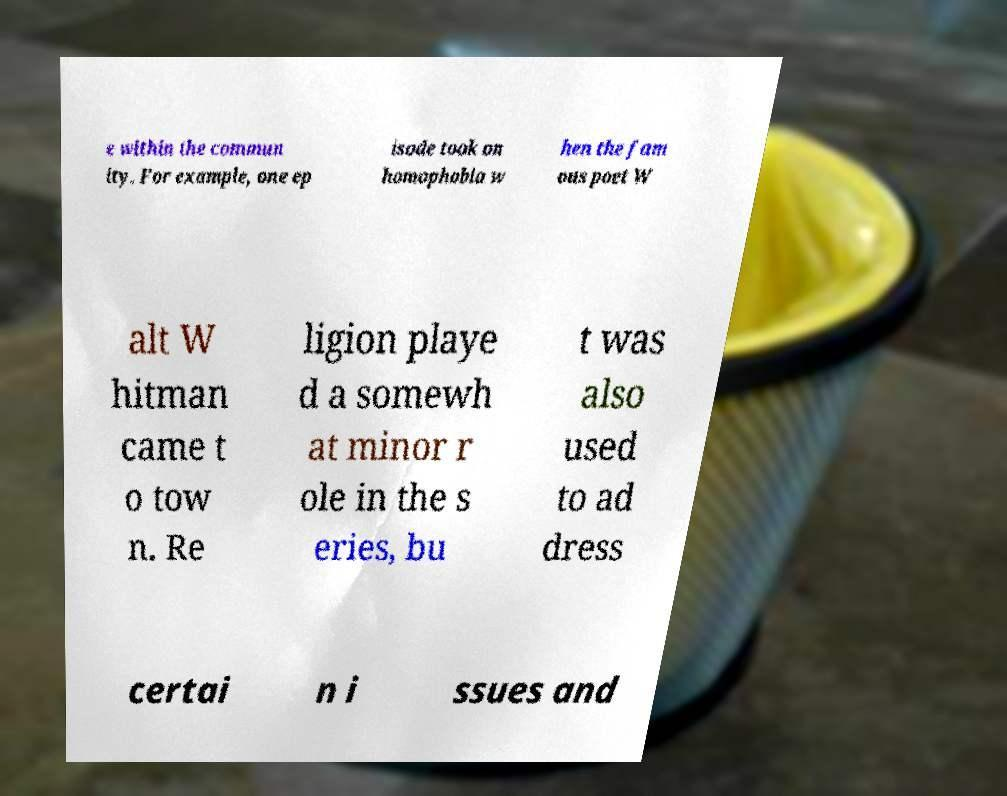Can you read and provide the text displayed in the image?This photo seems to have some interesting text. Can you extract and type it out for me? e within the commun ity. For example, one ep isode took on homophobia w hen the fam ous poet W alt W hitman came t o tow n. Re ligion playe d a somewh at minor r ole in the s eries, bu t was also used to ad dress certai n i ssues and 